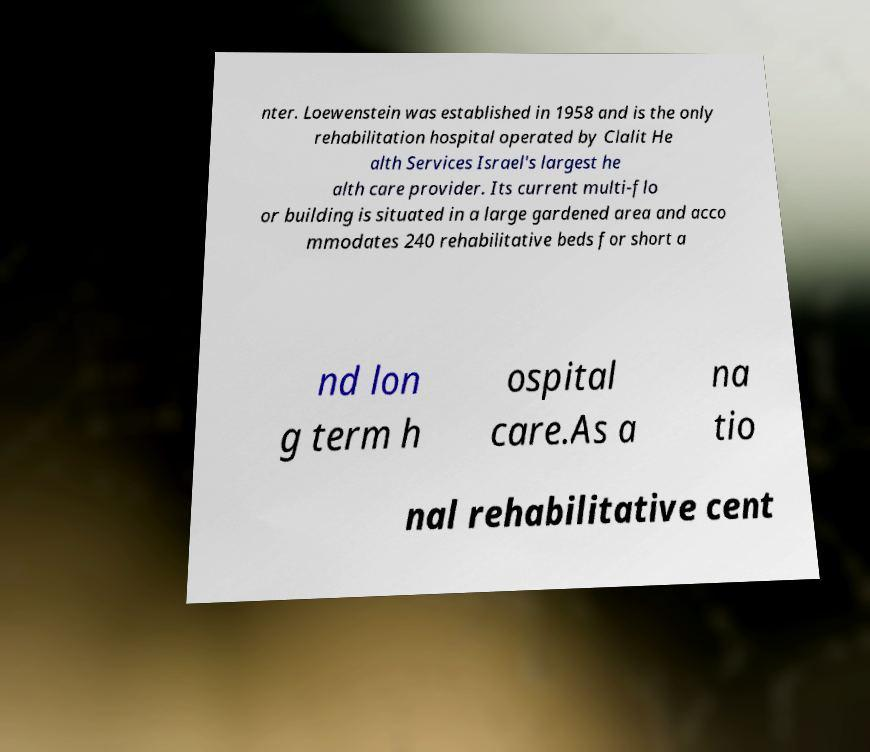Can you accurately transcribe the text from the provided image for me? nter. Loewenstein was established in 1958 and is the only rehabilitation hospital operated by Clalit He alth Services Israel's largest he alth care provider. Its current multi-flo or building is situated in a large gardened area and acco mmodates 240 rehabilitative beds for short a nd lon g term h ospital care.As a na tio nal rehabilitative cent 